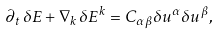<formula> <loc_0><loc_0><loc_500><loc_500>\partial _ { t } \, \delta E + \nabla _ { k } \, \delta E ^ { k } = C _ { \alpha \beta } \delta u ^ { \alpha } \delta u ^ { \beta } ,</formula> 